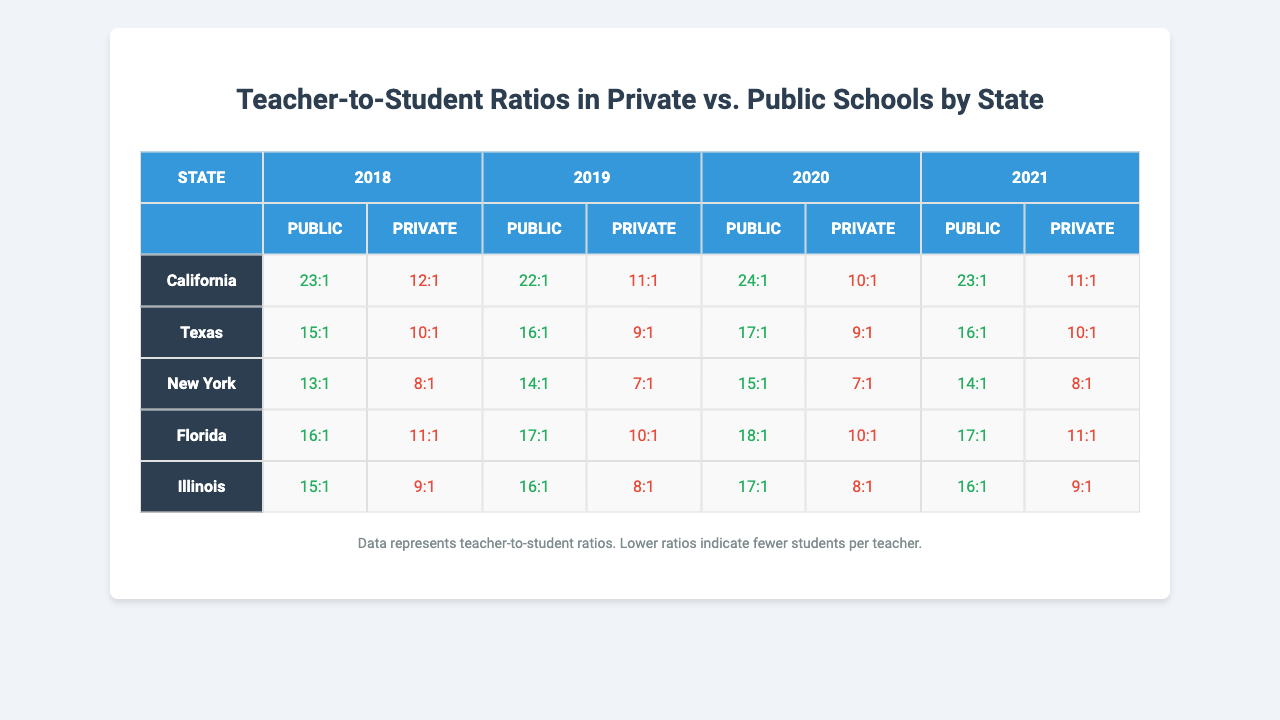What is the teacher-to-student ratio for private schools in New York in 2020? The table indicates that in 2020, the private school teacher-to-student ratio in New York was 7:1.
Answer: 7:1 What was the public school teacher-to-student ratio in Florida in 2019? According to the table, the public school teacher-to-student ratio in Florida for 2019 was 16:1.
Answer: 16:1 Which state had the lowest private school teacher-to-student ratio in 2021? Looking at the table for the year 2021, New York has the lowest private school teacher-to-student ratio at 8:1.
Answer: New York What was the average teacher-to-student ratio for public schools across all states in 2018? The public school ratios for 2018 are: California 23, Texas 15, New York 13, Florida 16, Illinois 15. Summing these gives 23 + 15 + 13 + 16 + 15 = 82. There are 5 states, so 82 divided by 5 gives an average of 16.4.
Answer: 16.4 In which year did Texas have a private school ratio that was lower than the public school ratio? In 2018, Texas had a private school ratio of 10, which is lower than the public school ratio of 15. This pattern continues for 2019 (private 9 vs public 16), and 2020 (private 9 vs public 17).
Answer: 2018, 2019, 2020 What is the difference between the public and private school ratios in California for 2020? The public ratio in California for 2020 is 24:1, and the private ratio is 10:1. The difference is calculated as 24 - 10 = 14.
Answer: 14 Has the public school ratio in Illinois improved, remained the same, or worsened from 2018 to 2021? In Illinois, the public school ratios were 15 in 2018 and 16 in 2021. An increase from 15 to 16 indicates that it has worsened.
Answer: Worsened Which state shows the largest decrease in the teacher-to-student ratio for private schools from 2018 to 2021? Looking at the private school ratios from 2018 to 2021, California went from 12:1 in 2018 to 11:1 in 2021, a decrease of 1. In comparison, New York went from 8:1 to 8:1 (no change), and Florida from 12:1 to 10:1 (decrease of 2). So, the largest decrease is in Florida.
Answer: Florida What is the trend for the teacher-to-student ratio in public schools in California from 2018 to 2021? Observing the public school ratios in California: 2018 was 23:1, then 22:1 in 2019, increasing to 24:1 in 2020, and finally 23:1 in 2021. Thus, after a decrease from 2018 to 2019, there is an increase in 2020 followed by a small decrease again in 2021.
Answer: Fluctuating Is the teacher-to-student ratio for private schools generally lower than that for public schools across all years for Texas? Evaluating the ratios for Texas: Public ratios are 15:1 (2018), 16:1 (2019), 17:1 (2020), and 16:1 (2021). The private ratios are 10:1 (2018), 9:1 (2019), 9:1 (2020), and 10:1 (2021). Since private ratios are consistently lower in all years, the statement is true.
Answer: Yes 